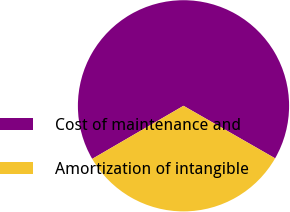Convert chart. <chart><loc_0><loc_0><loc_500><loc_500><pie_chart><fcel>Cost of maintenance and<fcel>Amortization of intangible<nl><fcel>66.67%<fcel>33.33%<nl></chart> 